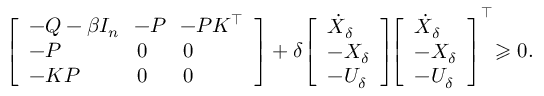<formula> <loc_0><loc_0><loc_500><loc_500>\left [ \begin{array} { l l l } { - Q - \beta I _ { n } \, } & { \, - P \, } & { \, - P K ^ { \top } } \\ { - P } & { 0 } & { 0 } \\ { - K P } & { 0 } & { 0 } \end{array} \right ] + \delta \, \left [ \begin{array} { l } { \dot { X } _ { \delta } } \\ { - X _ { \delta } } \\ { - U _ { \delta } } \end{array} \right ] \, \left [ \begin{array} { l } { \dot { X } _ { \delta } } \\ { - X _ { \delta } } \\ { - U _ { \delta } } \end{array} \right ] ^ { \top } \, \geqslant 0 .</formula> 